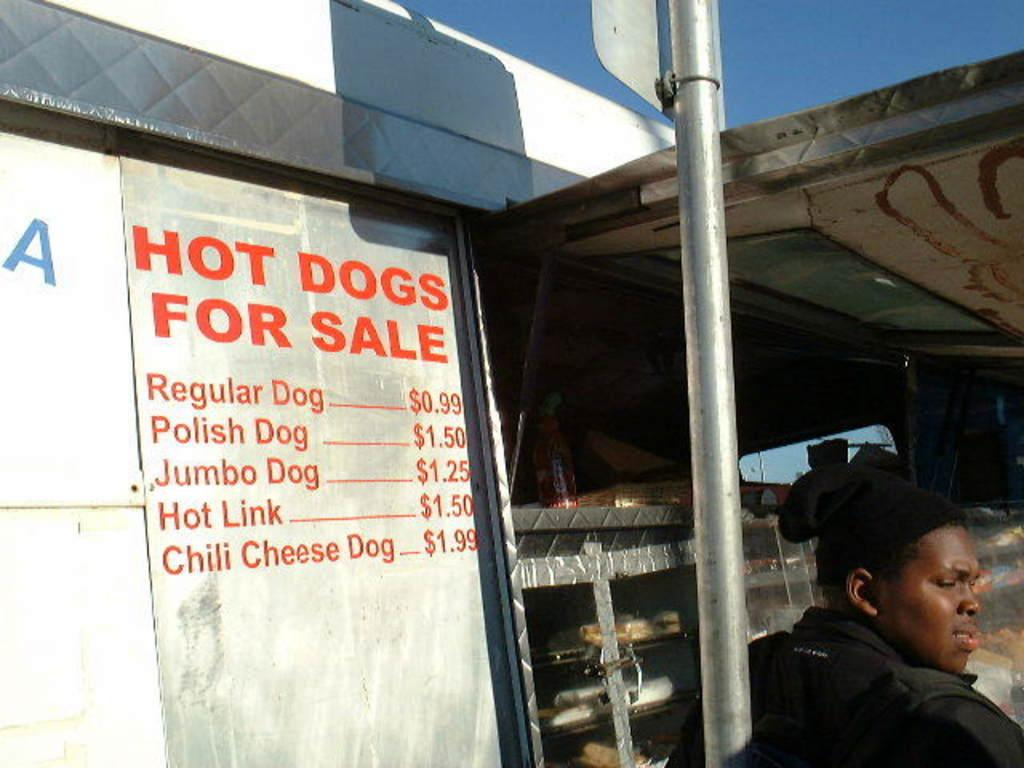Who is present in the image? There is a person in the image. What is the person wearing? The person is wearing a black dress. What can be seen in the background of the image? There is a stall in the background of the image. What is the color of the sky in the image? The sky is blue in the image. What type of pie is being served at the stall in the image? There is no pie present in the image, nor is there any indication of a stall serving pie. 